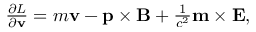Convert formula to latex. <formula><loc_0><loc_0><loc_500><loc_500>\begin{array} { r } { \frac { \partial L } { \partial \mathbf v } = m \mathbf v - \mathbf p \times \mathbf B + \frac { 1 } { c ^ { 2 } } \mathbf m \times \mathbf E , } \end{array}</formula> 